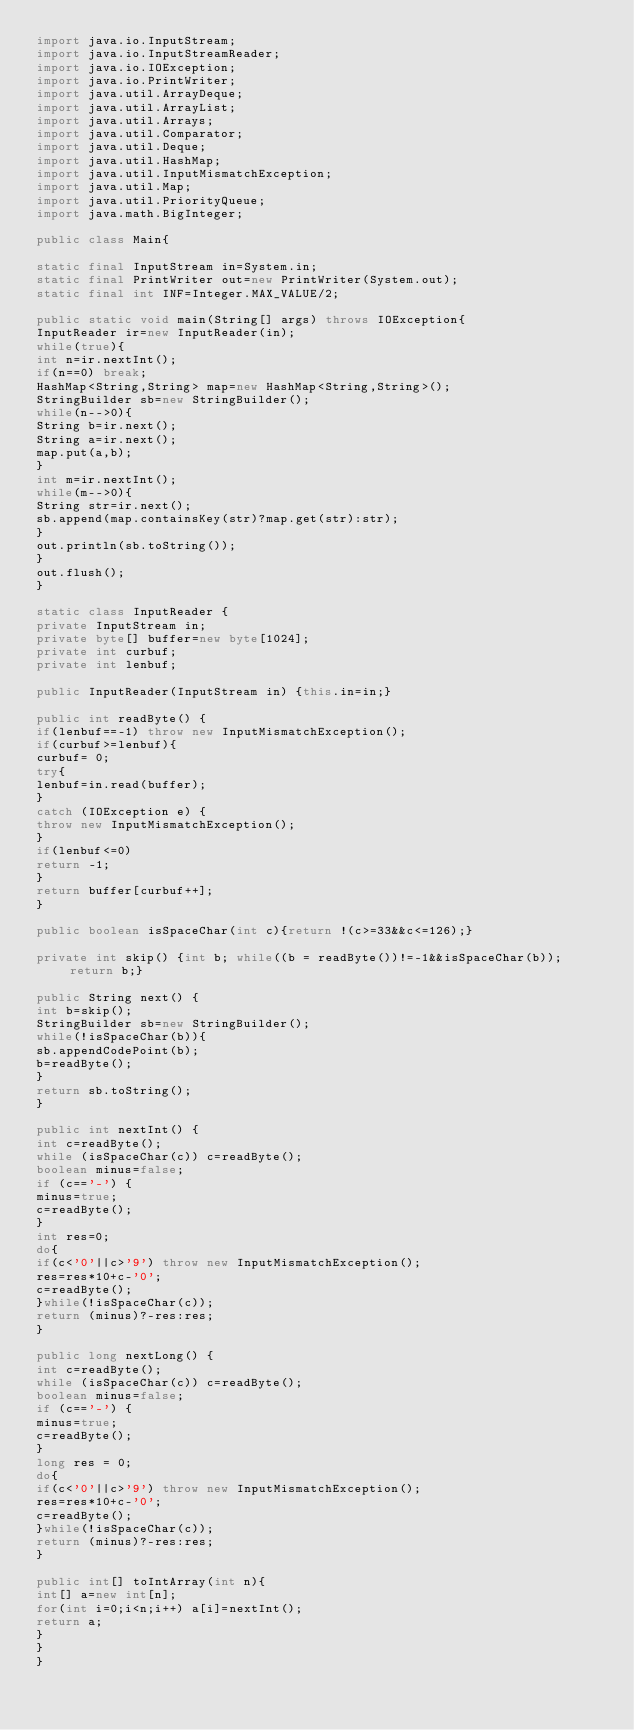Convert code to text. <code><loc_0><loc_0><loc_500><loc_500><_Java_>import java.io.InputStream;
import java.io.InputStreamReader;
import java.io.IOException;
import java.io.PrintWriter;
import java.util.ArrayDeque;
import java.util.ArrayList;
import java.util.Arrays;
import java.util.Comparator;
import java.util.Deque;
import java.util.HashMap;
import java.util.InputMismatchException;
import java.util.Map;
import java.util.PriorityQueue;
import java.math.BigInteger;
    
public class Main{

static final InputStream in=System.in;
static final PrintWriter out=new PrintWriter(System.out);
static final int INF=Integer.MAX_VALUE/2;

public static void main(String[] args) throws IOException{
InputReader ir=new InputReader(in);
while(true){
int n=ir.nextInt();
if(n==0) break;
HashMap<String,String> map=new HashMap<String,String>();
StringBuilder sb=new StringBuilder();
while(n-->0){
String b=ir.next();
String a=ir.next();
map.put(a,b);
}
int m=ir.nextInt();
while(m-->0){
String str=ir.next();
sb.append(map.containsKey(str)?map.get(str):str);
}
out.println(sb.toString());
}
out.flush();
}

static class InputReader {
private InputStream in;
private byte[] buffer=new byte[1024];
private int curbuf;
private int lenbuf;

public InputReader(InputStream in) {this.in=in;}
  
public int readByte() {
if(lenbuf==-1) throw new InputMismatchException();
if(curbuf>=lenbuf){
curbuf= 0;
try{
lenbuf=in.read(buffer);
}
catch (IOException e) {
throw new InputMismatchException();
}
if(lenbuf<=0)
return -1;
}
return buffer[curbuf++];
}

public boolean isSpaceChar(int c){return !(c>=33&&c<=126);}

private int skip() {int b; while((b = readByte())!=-1&&isSpaceChar(b)); return b;}

public String next() {
int b=skip();
StringBuilder sb=new StringBuilder();
while(!isSpaceChar(b)){
sb.appendCodePoint(b);
b=readByte();
}
return sb.toString();
}
 
public int nextInt() {
int c=readByte();
while (isSpaceChar(c)) c=readByte();
boolean minus=false;
if (c=='-') {
minus=true;
c=readByte();
}
int res=0;
do{
if(c<'0'||c>'9') throw new InputMismatchException();
res=res*10+c-'0';
c=readByte();
}while(!isSpaceChar(c));
return (minus)?-res:res;
}

public long nextLong() {
int c=readByte();
while (isSpaceChar(c)) c=readByte();
boolean minus=false;
if (c=='-') {
minus=true;
c=readByte();
}
long res = 0;
do{
if(c<'0'||c>'9') throw new InputMismatchException();
res=res*10+c-'0';
c=readByte();
}while(!isSpaceChar(c));
return (minus)?-res:res;
}

public int[] toIntArray(int n){
int[] a=new int[n];
for(int i=0;i<n;i++) a[i]=nextInt();
return a;
}
}
}</code> 